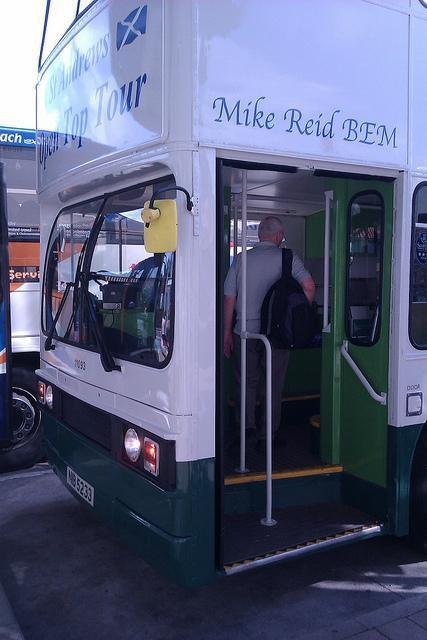How many buses are there?
Give a very brief answer. 2. How many backpacks are in the photo?
Give a very brief answer. 1. 